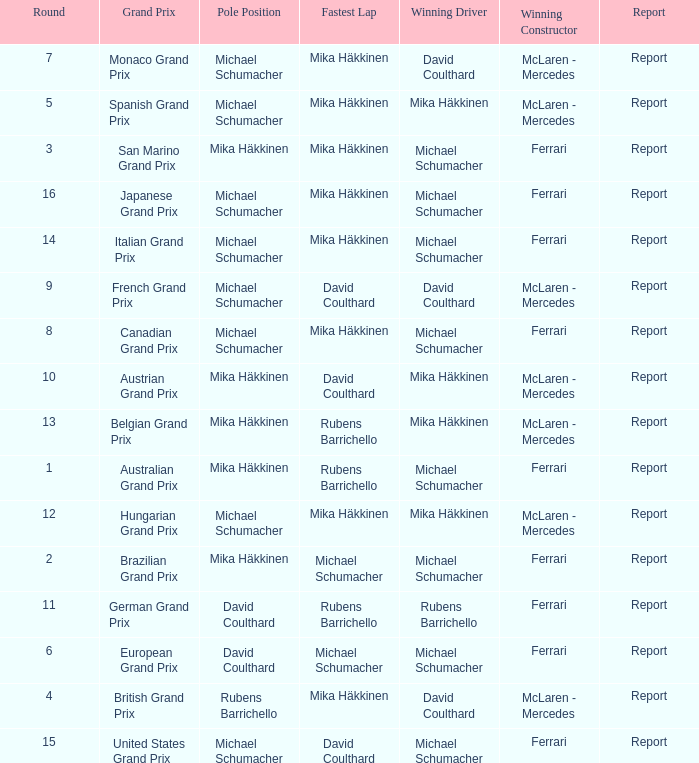Who had the fastest lap in the Belgian Grand Prix? Rubens Barrichello. 